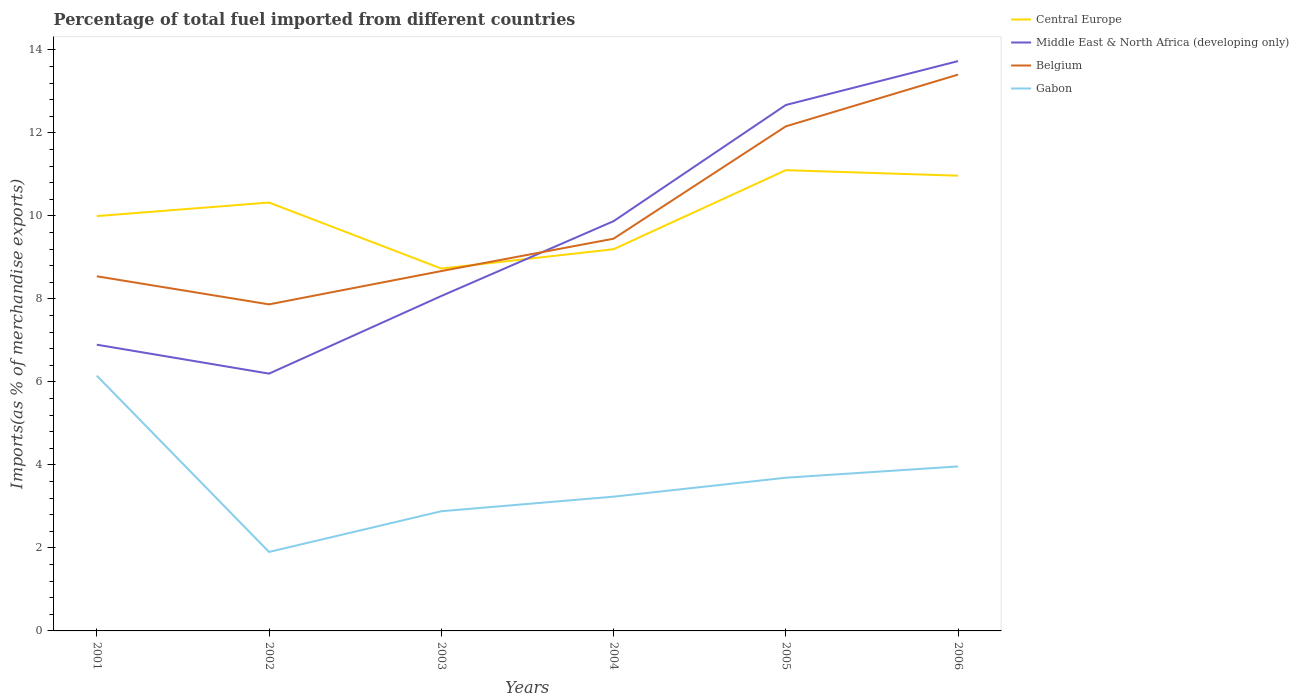Is the number of lines equal to the number of legend labels?
Offer a terse response. Yes. Across all years, what is the maximum percentage of imports to different countries in Gabon?
Offer a terse response. 1.9. What is the total percentage of imports to different countries in Belgium in the graph?
Your response must be concise. -4.73. What is the difference between the highest and the second highest percentage of imports to different countries in Belgium?
Keep it short and to the point. 5.54. Is the percentage of imports to different countries in Belgium strictly greater than the percentage of imports to different countries in Middle East & North Africa (developing only) over the years?
Give a very brief answer. No. How many years are there in the graph?
Ensure brevity in your answer.  6. What is the difference between two consecutive major ticks on the Y-axis?
Offer a terse response. 2. Are the values on the major ticks of Y-axis written in scientific E-notation?
Provide a short and direct response. No. Does the graph contain any zero values?
Provide a succinct answer. No. Does the graph contain grids?
Keep it short and to the point. No. How many legend labels are there?
Your answer should be compact. 4. What is the title of the graph?
Provide a succinct answer. Percentage of total fuel imported from different countries. Does "Dominica" appear as one of the legend labels in the graph?
Give a very brief answer. No. What is the label or title of the X-axis?
Ensure brevity in your answer.  Years. What is the label or title of the Y-axis?
Provide a short and direct response. Imports(as % of merchandise exports). What is the Imports(as % of merchandise exports) in Central Europe in 2001?
Offer a very short reply. 9.99. What is the Imports(as % of merchandise exports) in Middle East & North Africa (developing only) in 2001?
Provide a succinct answer. 6.9. What is the Imports(as % of merchandise exports) in Belgium in 2001?
Keep it short and to the point. 8.54. What is the Imports(as % of merchandise exports) in Gabon in 2001?
Your answer should be very brief. 6.15. What is the Imports(as % of merchandise exports) of Central Europe in 2002?
Give a very brief answer. 10.32. What is the Imports(as % of merchandise exports) of Middle East & North Africa (developing only) in 2002?
Give a very brief answer. 6.2. What is the Imports(as % of merchandise exports) of Belgium in 2002?
Make the answer very short. 7.87. What is the Imports(as % of merchandise exports) of Gabon in 2002?
Offer a very short reply. 1.9. What is the Imports(as % of merchandise exports) of Central Europe in 2003?
Your answer should be compact. 8.73. What is the Imports(as % of merchandise exports) in Middle East & North Africa (developing only) in 2003?
Offer a very short reply. 8.07. What is the Imports(as % of merchandise exports) in Belgium in 2003?
Keep it short and to the point. 8.67. What is the Imports(as % of merchandise exports) of Gabon in 2003?
Offer a terse response. 2.88. What is the Imports(as % of merchandise exports) in Central Europe in 2004?
Ensure brevity in your answer.  9.2. What is the Imports(as % of merchandise exports) of Middle East & North Africa (developing only) in 2004?
Your answer should be very brief. 9.87. What is the Imports(as % of merchandise exports) of Belgium in 2004?
Provide a short and direct response. 9.45. What is the Imports(as % of merchandise exports) in Gabon in 2004?
Offer a very short reply. 3.23. What is the Imports(as % of merchandise exports) in Central Europe in 2005?
Your answer should be compact. 11.1. What is the Imports(as % of merchandise exports) in Middle East & North Africa (developing only) in 2005?
Your response must be concise. 12.67. What is the Imports(as % of merchandise exports) of Belgium in 2005?
Your answer should be very brief. 12.16. What is the Imports(as % of merchandise exports) of Gabon in 2005?
Keep it short and to the point. 3.69. What is the Imports(as % of merchandise exports) in Central Europe in 2006?
Give a very brief answer. 10.97. What is the Imports(as % of merchandise exports) of Middle East & North Africa (developing only) in 2006?
Ensure brevity in your answer.  13.73. What is the Imports(as % of merchandise exports) in Belgium in 2006?
Provide a succinct answer. 13.4. What is the Imports(as % of merchandise exports) of Gabon in 2006?
Give a very brief answer. 3.96. Across all years, what is the maximum Imports(as % of merchandise exports) in Central Europe?
Ensure brevity in your answer.  11.1. Across all years, what is the maximum Imports(as % of merchandise exports) in Middle East & North Africa (developing only)?
Provide a short and direct response. 13.73. Across all years, what is the maximum Imports(as % of merchandise exports) in Belgium?
Provide a succinct answer. 13.4. Across all years, what is the maximum Imports(as % of merchandise exports) of Gabon?
Offer a very short reply. 6.15. Across all years, what is the minimum Imports(as % of merchandise exports) of Central Europe?
Keep it short and to the point. 8.73. Across all years, what is the minimum Imports(as % of merchandise exports) in Middle East & North Africa (developing only)?
Your answer should be very brief. 6.2. Across all years, what is the minimum Imports(as % of merchandise exports) of Belgium?
Give a very brief answer. 7.87. Across all years, what is the minimum Imports(as % of merchandise exports) of Gabon?
Give a very brief answer. 1.9. What is the total Imports(as % of merchandise exports) of Central Europe in the graph?
Make the answer very short. 60.31. What is the total Imports(as % of merchandise exports) in Middle East & North Africa (developing only) in the graph?
Provide a short and direct response. 57.44. What is the total Imports(as % of merchandise exports) in Belgium in the graph?
Offer a very short reply. 60.09. What is the total Imports(as % of merchandise exports) in Gabon in the graph?
Offer a terse response. 21.83. What is the difference between the Imports(as % of merchandise exports) in Central Europe in 2001 and that in 2002?
Offer a terse response. -0.33. What is the difference between the Imports(as % of merchandise exports) in Middle East & North Africa (developing only) in 2001 and that in 2002?
Your answer should be very brief. 0.7. What is the difference between the Imports(as % of merchandise exports) of Belgium in 2001 and that in 2002?
Provide a short and direct response. 0.68. What is the difference between the Imports(as % of merchandise exports) in Gabon in 2001 and that in 2002?
Your response must be concise. 4.25. What is the difference between the Imports(as % of merchandise exports) in Central Europe in 2001 and that in 2003?
Ensure brevity in your answer.  1.26. What is the difference between the Imports(as % of merchandise exports) of Middle East & North Africa (developing only) in 2001 and that in 2003?
Provide a short and direct response. -1.17. What is the difference between the Imports(as % of merchandise exports) in Belgium in 2001 and that in 2003?
Keep it short and to the point. -0.13. What is the difference between the Imports(as % of merchandise exports) of Gabon in 2001 and that in 2003?
Provide a succinct answer. 3.27. What is the difference between the Imports(as % of merchandise exports) of Central Europe in 2001 and that in 2004?
Provide a short and direct response. 0.8. What is the difference between the Imports(as % of merchandise exports) in Middle East & North Africa (developing only) in 2001 and that in 2004?
Offer a very short reply. -2.98. What is the difference between the Imports(as % of merchandise exports) of Belgium in 2001 and that in 2004?
Your response must be concise. -0.91. What is the difference between the Imports(as % of merchandise exports) in Gabon in 2001 and that in 2004?
Make the answer very short. 2.92. What is the difference between the Imports(as % of merchandise exports) in Central Europe in 2001 and that in 2005?
Give a very brief answer. -1.11. What is the difference between the Imports(as % of merchandise exports) in Middle East & North Africa (developing only) in 2001 and that in 2005?
Your answer should be very brief. -5.77. What is the difference between the Imports(as % of merchandise exports) in Belgium in 2001 and that in 2005?
Your answer should be very brief. -3.61. What is the difference between the Imports(as % of merchandise exports) of Gabon in 2001 and that in 2005?
Offer a very short reply. 2.46. What is the difference between the Imports(as % of merchandise exports) in Central Europe in 2001 and that in 2006?
Give a very brief answer. -0.97. What is the difference between the Imports(as % of merchandise exports) of Middle East & North Africa (developing only) in 2001 and that in 2006?
Make the answer very short. -6.83. What is the difference between the Imports(as % of merchandise exports) of Belgium in 2001 and that in 2006?
Offer a very short reply. -4.86. What is the difference between the Imports(as % of merchandise exports) in Gabon in 2001 and that in 2006?
Offer a very short reply. 2.19. What is the difference between the Imports(as % of merchandise exports) in Central Europe in 2002 and that in 2003?
Provide a short and direct response. 1.59. What is the difference between the Imports(as % of merchandise exports) in Middle East & North Africa (developing only) in 2002 and that in 2003?
Ensure brevity in your answer.  -1.87. What is the difference between the Imports(as % of merchandise exports) of Belgium in 2002 and that in 2003?
Your answer should be very brief. -0.8. What is the difference between the Imports(as % of merchandise exports) in Gabon in 2002 and that in 2003?
Give a very brief answer. -0.98. What is the difference between the Imports(as % of merchandise exports) of Middle East & North Africa (developing only) in 2002 and that in 2004?
Ensure brevity in your answer.  -3.67. What is the difference between the Imports(as % of merchandise exports) in Belgium in 2002 and that in 2004?
Keep it short and to the point. -1.58. What is the difference between the Imports(as % of merchandise exports) in Gabon in 2002 and that in 2004?
Offer a very short reply. -1.33. What is the difference between the Imports(as % of merchandise exports) of Central Europe in 2002 and that in 2005?
Your answer should be very brief. -0.78. What is the difference between the Imports(as % of merchandise exports) of Middle East & North Africa (developing only) in 2002 and that in 2005?
Offer a terse response. -6.47. What is the difference between the Imports(as % of merchandise exports) in Belgium in 2002 and that in 2005?
Offer a terse response. -4.29. What is the difference between the Imports(as % of merchandise exports) of Gabon in 2002 and that in 2005?
Give a very brief answer. -1.79. What is the difference between the Imports(as % of merchandise exports) of Central Europe in 2002 and that in 2006?
Provide a short and direct response. -0.65. What is the difference between the Imports(as % of merchandise exports) of Middle East & North Africa (developing only) in 2002 and that in 2006?
Keep it short and to the point. -7.53. What is the difference between the Imports(as % of merchandise exports) in Belgium in 2002 and that in 2006?
Your response must be concise. -5.54. What is the difference between the Imports(as % of merchandise exports) of Gabon in 2002 and that in 2006?
Provide a succinct answer. -2.06. What is the difference between the Imports(as % of merchandise exports) of Central Europe in 2003 and that in 2004?
Offer a terse response. -0.47. What is the difference between the Imports(as % of merchandise exports) of Middle East & North Africa (developing only) in 2003 and that in 2004?
Provide a short and direct response. -1.8. What is the difference between the Imports(as % of merchandise exports) in Belgium in 2003 and that in 2004?
Offer a terse response. -0.78. What is the difference between the Imports(as % of merchandise exports) in Gabon in 2003 and that in 2004?
Provide a short and direct response. -0.35. What is the difference between the Imports(as % of merchandise exports) of Central Europe in 2003 and that in 2005?
Ensure brevity in your answer.  -2.37. What is the difference between the Imports(as % of merchandise exports) in Middle East & North Africa (developing only) in 2003 and that in 2005?
Provide a short and direct response. -4.6. What is the difference between the Imports(as % of merchandise exports) of Belgium in 2003 and that in 2005?
Ensure brevity in your answer.  -3.49. What is the difference between the Imports(as % of merchandise exports) of Gabon in 2003 and that in 2005?
Provide a succinct answer. -0.81. What is the difference between the Imports(as % of merchandise exports) in Central Europe in 2003 and that in 2006?
Your response must be concise. -2.24. What is the difference between the Imports(as % of merchandise exports) in Middle East & North Africa (developing only) in 2003 and that in 2006?
Offer a very short reply. -5.66. What is the difference between the Imports(as % of merchandise exports) of Belgium in 2003 and that in 2006?
Provide a short and direct response. -4.73. What is the difference between the Imports(as % of merchandise exports) in Gabon in 2003 and that in 2006?
Provide a short and direct response. -1.08. What is the difference between the Imports(as % of merchandise exports) of Central Europe in 2004 and that in 2005?
Your answer should be compact. -1.9. What is the difference between the Imports(as % of merchandise exports) in Middle East & North Africa (developing only) in 2004 and that in 2005?
Your answer should be very brief. -2.8. What is the difference between the Imports(as % of merchandise exports) in Belgium in 2004 and that in 2005?
Give a very brief answer. -2.71. What is the difference between the Imports(as % of merchandise exports) in Gabon in 2004 and that in 2005?
Keep it short and to the point. -0.46. What is the difference between the Imports(as % of merchandise exports) of Central Europe in 2004 and that in 2006?
Provide a succinct answer. -1.77. What is the difference between the Imports(as % of merchandise exports) of Middle East & North Africa (developing only) in 2004 and that in 2006?
Offer a terse response. -3.86. What is the difference between the Imports(as % of merchandise exports) in Belgium in 2004 and that in 2006?
Your response must be concise. -3.95. What is the difference between the Imports(as % of merchandise exports) in Gabon in 2004 and that in 2006?
Your response must be concise. -0.73. What is the difference between the Imports(as % of merchandise exports) of Central Europe in 2005 and that in 2006?
Make the answer very short. 0.13. What is the difference between the Imports(as % of merchandise exports) of Middle East & North Africa (developing only) in 2005 and that in 2006?
Make the answer very short. -1.06. What is the difference between the Imports(as % of merchandise exports) in Belgium in 2005 and that in 2006?
Your answer should be compact. -1.25. What is the difference between the Imports(as % of merchandise exports) of Gabon in 2005 and that in 2006?
Offer a very short reply. -0.27. What is the difference between the Imports(as % of merchandise exports) in Central Europe in 2001 and the Imports(as % of merchandise exports) in Middle East & North Africa (developing only) in 2002?
Ensure brevity in your answer.  3.8. What is the difference between the Imports(as % of merchandise exports) in Central Europe in 2001 and the Imports(as % of merchandise exports) in Belgium in 2002?
Give a very brief answer. 2.13. What is the difference between the Imports(as % of merchandise exports) of Central Europe in 2001 and the Imports(as % of merchandise exports) of Gabon in 2002?
Your answer should be very brief. 8.09. What is the difference between the Imports(as % of merchandise exports) of Middle East & North Africa (developing only) in 2001 and the Imports(as % of merchandise exports) of Belgium in 2002?
Provide a succinct answer. -0.97. What is the difference between the Imports(as % of merchandise exports) in Middle East & North Africa (developing only) in 2001 and the Imports(as % of merchandise exports) in Gabon in 2002?
Your response must be concise. 4.99. What is the difference between the Imports(as % of merchandise exports) in Belgium in 2001 and the Imports(as % of merchandise exports) in Gabon in 2002?
Keep it short and to the point. 6.64. What is the difference between the Imports(as % of merchandise exports) of Central Europe in 2001 and the Imports(as % of merchandise exports) of Middle East & North Africa (developing only) in 2003?
Provide a short and direct response. 1.93. What is the difference between the Imports(as % of merchandise exports) of Central Europe in 2001 and the Imports(as % of merchandise exports) of Belgium in 2003?
Make the answer very short. 1.32. What is the difference between the Imports(as % of merchandise exports) in Central Europe in 2001 and the Imports(as % of merchandise exports) in Gabon in 2003?
Keep it short and to the point. 7.11. What is the difference between the Imports(as % of merchandise exports) of Middle East & North Africa (developing only) in 2001 and the Imports(as % of merchandise exports) of Belgium in 2003?
Keep it short and to the point. -1.77. What is the difference between the Imports(as % of merchandise exports) of Middle East & North Africa (developing only) in 2001 and the Imports(as % of merchandise exports) of Gabon in 2003?
Offer a very short reply. 4.01. What is the difference between the Imports(as % of merchandise exports) in Belgium in 2001 and the Imports(as % of merchandise exports) in Gabon in 2003?
Make the answer very short. 5.66. What is the difference between the Imports(as % of merchandise exports) of Central Europe in 2001 and the Imports(as % of merchandise exports) of Middle East & North Africa (developing only) in 2004?
Offer a terse response. 0.12. What is the difference between the Imports(as % of merchandise exports) of Central Europe in 2001 and the Imports(as % of merchandise exports) of Belgium in 2004?
Your response must be concise. 0.54. What is the difference between the Imports(as % of merchandise exports) of Central Europe in 2001 and the Imports(as % of merchandise exports) of Gabon in 2004?
Offer a terse response. 6.76. What is the difference between the Imports(as % of merchandise exports) of Middle East & North Africa (developing only) in 2001 and the Imports(as % of merchandise exports) of Belgium in 2004?
Your answer should be very brief. -2.55. What is the difference between the Imports(as % of merchandise exports) in Middle East & North Africa (developing only) in 2001 and the Imports(as % of merchandise exports) in Gabon in 2004?
Offer a very short reply. 3.66. What is the difference between the Imports(as % of merchandise exports) in Belgium in 2001 and the Imports(as % of merchandise exports) in Gabon in 2004?
Ensure brevity in your answer.  5.31. What is the difference between the Imports(as % of merchandise exports) of Central Europe in 2001 and the Imports(as % of merchandise exports) of Middle East & North Africa (developing only) in 2005?
Your answer should be very brief. -2.68. What is the difference between the Imports(as % of merchandise exports) in Central Europe in 2001 and the Imports(as % of merchandise exports) in Belgium in 2005?
Give a very brief answer. -2.16. What is the difference between the Imports(as % of merchandise exports) in Central Europe in 2001 and the Imports(as % of merchandise exports) in Gabon in 2005?
Your answer should be compact. 6.3. What is the difference between the Imports(as % of merchandise exports) of Middle East & North Africa (developing only) in 2001 and the Imports(as % of merchandise exports) of Belgium in 2005?
Provide a short and direct response. -5.26. What is the difference between the Imports(as % of merchandise exports) in Middle East & North Africa (developing only) in 2001 and the Imports(as % of merchandise exports) in Gabon in 2005?
Give a very brief answer. 3.21. What is the difference between the Imports(as % of merchandise exports) in Belgium in 2001 and the Imports(as % of merchandise exports) in Gabon in 2005?
Your answer should be very brief. 4.85. What is the difference between the Imports(as % of merchandise exports) of Central Europe in 2001 and the Imports(as % of merchandise exports) of Middle East & North Africa (developing only) in 2006?
Your answer should be very brief. -3.73. What is the difference between the Imports(as % of merchandise exports) in Central Europe in 2001 and the Imports(as % of merchandise exports) in Belgium in 2006?
Your answer should be very brief. -3.41. What is the difference between the Imports(as % of merchandise exports) in Central Europe in 2001 and the Imports(as % of merchandise exports) in Gabon in 2006?
Provide a short and direct response. 6.03. What is the difference between the Imports(as % of merchandise exports) in Middle East & North Africa (developing only) in 2001 and the Imports(as % of merchandise exports) in Belgium in 2006?
Your answer should be compact. -6.51. What is the difference between the Imports(as % of merchandise exports) in Middle East & North Africa (developing only) in 2001 and the Imports(as % of merchandise exports) in Gabon in 2006?
Offer a very short reply. 2.93. What is the difference between the Imports(as % of merchandise exports) in Belgium in 2001 and the Imports(as % of merchandise exports) in Gabon in 2006?
Offer a terse response. 4.58. What is the difference between the Imports(as % of merchandise exports) in Central Europe in 2002 and the Imports(as % of merchandise exports) in Middle East & North Africa (developing only) in 2003?
Make the answer very short. 2.25. What is the difference between the Imports(as % of merchandise exports) in Central Europe in 2002 and the Imports(as % of merchandise exports) in Belgium in 2003?
Offer a terse response. 1.65. What is the difference between the Imports(as % of merchandise exports) in Central Europe in 2002 and the Imports(as % of merchandise exports) in Gabon in 2003?
Offer a terse response. 7.44. What is the difference between the Imports(as % of merchandise exports) of Middle East & North Africa (developing only) in 2002 and the Imports(as % of merchandise exports) of Belgium in 2003?
Ensure brevity in your answer.  -2.47. What is the difference between the Imports(as % of merchandise exports) of Middle East & North Africa (developing only) in 2002 and the Imports(as % of merchandise exports) of Gabon in 2003?
Ensure brevity in your answer.  3.32. What is the difference between the Imports(as % of merchandise exports) in Belgium in 2002 and the Imports(as % of merchandise exports) in Gabon in 2003?
Offer a terse response. 4.98. What is the difference between the Imports(as % of merchandise exports) of Central Europe in 2002 and the Imports(as % of merchandise exports) of Middle East & North Africa (developing only) in 2004?
Offer a very short reply. 0.45. What is the difference between the Imports(as % of merchandise exports) in Central Europe in 2002 and the Imports(as % of merchandise exports) in Belgium in 2004?
Your response must be concise. 0.87. What is the difference between the Imports(as % of merchandise exports) in Central Europe in 2002 and the Imports(as % of merchandise exports) in Gabon in 2004?
Offer a very short reply. 7.09. What is the difference between the Imports(as % of merchandise exports) of Middle East & North Africa (developing only) in 2002 and the Imports(as % of merchandise exports) of Belgium in 2004?
Ensure brevity in your answer.  -3.25. What is the difference between the Imports(as % of merchandise exports) in Middle East & North Africa (developing only) in 2002 and the Imports(as % of merchandise exports) in Gabon in 2004?
Provide a succinct answer. 2.96. What is the difference between the Imports(as % of merchandise exports) in Belgium in 2002 and the Imports(as % of merchandise exports) in Gabon in 2004?
Make the answer very short. 4.63. What is the difference between the Imports(as % of merchandise exports) of Central Europe in 2002 and the Imports(as % of merchandise exports) of Middle East & North Africa (developing only) in 2005?
Your response must be concise. -2.35. What is the difference between the Imports(as % of merchandise exports) in Central Europe in 2002 and the Imports(as % of merchandise exports) in Belgium in 2005?
Your response must be concise. -1.84. What is the difference between the Imports(as % of merchandise exports) of Central Europe in 2002 and the Imports(as % of merchandise exports) of Gabon in 2005?
Make the answer very short. 6.63. What is the difference between the Imports(as % of merchandise exports) of Middle East & North Africa (developing only) in 2002 and the Imports(as % of merchandise exports) of Belgium in 2005?
Your answer should be compact. -5.96. What is the difference between the Imports(as % of merchandise exports) of Middle East & North Africa (developing only) in 2002 and the Imports(as % of merchandise exports) of Gabon in 2005?
Keep it short and to the point. 2.51. What is the difference between the Imports(as % of merchandise exports) of Belgium in 2002 and the Imports(as % of merchandise exports) of Gabon in 2005?
Your response must be concise. 4.18. What is the difference between the Imports(as % of merchandise exports) in Central Europe in 2002 and the Imports(as % of merchandise exports) in Middle East & North Africa (developing only) in 2006?
Your answer should be very brief. -3.41. What is the difference between the Imports(as % of merchandise exports) of Central Europe in 2002 and the Imports(as % of merchandise exports) of Belgium in 2006?
Keep it short and to the point. -3.08. What is the difference between the Imports(as % of merchandise exports) in Central Europe in 2002 and the Imports(as % of merchandise exports) in Gabon in 2006?
Ensure brevity in your answer.  6.36. What is the difference between the Imports(as % of merchandise exports) in Middle East & North Africa (developing only) in 2002 and the Imports(as % of merchandise exports) in Belgium in 2006?
Your response must be concise. -7.2. What is the difference between the Imports(as % of merchandise exports) of Middle East & North Africa (developing only) in 2002 and the Imports(as % of merchandise exports) of Gabon in 2006?
Keep it short and to the point. 2.24. What is the difference between the Imports(as % of merchandise exports) in Belgium in 2002 and the Imports(as % of merchandise exports) in Gabon in 2006?
Make the answer very short. 3.9. What is the difference between the Imports(as % of merchandise exports) of Central Europe in 2003 and the Imports(as % of merchandise exports) of Middle East & North Africa (developing only) in 2004?
Provide a succinct answer. -1.14. What is the difference between the Imports(as % of merchandise exports) in Central Europe in 2003 and the Imports(as % of merchandise exports) in Belgium in 2004?
Your response must be concise. -0.72. What is the difference between the Imports(as % of merchandise exports) of Central Europe in 2003 and the Imports(as % of merchandise exports) of Gabon in 2004?
Make the answer very short. 5.5. What is the difference between the Imports(as % of merchandise exports) in Middle East & North Africa (developing only) in 2003 and the Imports(as % of merchandise exports) in Belgium in 2004?
Provide a short and direct response. -1.38. What is the difference between the Imports(as % of merchandise exports) of Middle East & North Africa (developing only) in 2003 and the Imports(as % of merchandise exports) of Gabon in 2004?
Offer a terse response. 4.83. What is the difference between the Imports(as % of merchandise exports) in Belgium in 2003 and the Imports(as % of merchandise exports) in Gabon in 2004?
Keep it short and to the point. 5.44. What is the difference between the Imports(as % of merchandise exports) in Central Europe in 2003 and the Imports(as % of merchandise exports) in Middle East & North Africa (developing only) in 2005?
Provide a succinct answer. -3.94. What is the difference between the Imports(as % of merchandise exports) of Central Europe in 2003 and the Imports(as % of merchandise exports) of Belgium in 2005?
Provide a succinct answer. -3.43. What is the difference between the Imports(as % of merchandise exports) of Central Europe in 2003 and the Imports(as % of merchandise exports) of Gabon in 2005?
Provide a short and direct response. 5.04. What is the difference between the Imports(as % of merchandise exports) in Middle East & North Africa (developing only) in 2003 and the Imports(as % of merchandise exports) in Belgium in 2005?
Your answer should be very brief. -4.09. What is the difference between the Imports(as % of merchandise exports) of Middle East & North Africa (developing only) in 2003 and the Imports(as % of merchandise exports) of Gabon in 2005?
Ensure brevity in your answer.  4.38. What is the difference between the Imports(as % of merchandise exports) of Belgium in 2003 and the Imports(as % of merchandise exports) of Gabon in 2005?
Make the answer very short. 4.98. What is the difference between the Imports(as % of merchandise exports) in Central Europe in 2003 and the Imports(as % of merchandise exports) in Middle East & North Africa (developing only) in 2006?
Give a very brief answer. -5. What is the difference between the Imports(as % of merchandise exports) of Central Europe in 2003 and the Imports(as % of merchandise exports) of Belgium in 2006?
Give a very brief answer. -4.67. What is the difference between the Imports(as % of merchandise exports) of Central Europe in 2003 and the Imports(as % of merchandise exports) of Gabon in 2006?
Provide a succinct answer. 4.77. What is the difference between the Imports(as % of merchandise exports) of Middle East & North Africa (developing only) in 2003 and the Imports(as % of merchandise exports) of Belgium in 2006?
Your response must be concise. -5.33. What is the difference between the Imports(as % of merchandise exports) in Middle East & North Africa (developing only) in 2003 and the Imports(as % of merchandise exports) in Gabon in 2006?
Provide a short and direct response. 4.11. What is the difference between the Imports(as % of merchandise exports) in Belgium in 2003 and the Imports(as % of merchandise exports) in Gabon in 2006?
Your answer should be very brief. 4.71. What is the difference between the Imports(as % of merchandise exports) in Central Europe in 2004 and the Imports(as % of merchandise exports) in Middle East & North Africa (developing only) in 2005?
Ensure brevity in your answer.  -3.47. What is the difference between the Imports(as % of merchandise exports) in Central Europe in 2004 and the Imports(as % of merchandise exports) in Belgium in 2005?
Your response must be concise. -2.96. What is the difference between the Imports(as % of merchandise exports) in Central Europe in 2004 and the Imports(as % of merchandise exports) in Gabon in 2005?
Make the answer very short. 5.51. What is the difference between the Imports(as % of merchandise exports) of Middle East & North Africa (developing only) in 2004 and the Imports(as % of merchandise exports) of Belgium in 2005?
Keep it short and to the point. -2.28. What is the difference between the Imports(as % of merchandise exports) of Middle East & North Africa (developing only) in 2004 and the Imports(as % of merchandise exports) of Gabon in 2005?
Your response must be concise. 6.18. What is the difference between the Imports(as % of merchandise exports) of Belgium in 2004 and the Imports(as % of merchandise exports) of Gabon in 2005?
Keep it short and to the point. 5.76. What is the difference between the Imports(as % of merchandise exports) of Central Europe in 2004 and the Imports(as % of merchandise exports) of Middle East & North Africa (developing only) in 2006?
Your answer should be very brief. -4.53. What is the difference between the Imports(as % of merchandise exports) in Central Europe in 2004 and the Imports(as % of merchandise exports) in Belgium in 2006?
Your answer should be very brief. -4.21. What is the difference between the Imports(as % of merchandise exports) of Central Europe in 2004 and the Imports(as % of merchandise exports) of Gabon in 2006?
Offer a terse response. 5.23. What is the difference between the Imports(as % of merchandise exports) in Middle East & North Africa (developing only) in 2004 and the Imports(as % of merchandise exports) in Belgium in 2006?
Your answer should be very brief. -3.53. What is the difference between the Imports(as % of merchandise exports) of Middle East & North Africa (developing only) in 2004 and the Imports(as % of merchandise exports) of Gabon in 2006?
Offer a terse response. 5.91. What is the difference between the Imports(as % of merchandise exports) of Belgium in 2004 and the Imports(as % of merchandise exports) of Gabon in 2006?
Ensure brevity in your answer.  5.49. What is the difference between the Imports(as % of merchandise exports) of Central Europe in 2005 and the Imports(as % of merchandise exports) of Middle East & North Africa (developing only) in 2006?
Offer a terse response. -2.63. What is the difference between the Imports(as % of merchandise exports) in Central Europe in 2005 and the Imports(as % of merchandise exports) in Belgium in 2006?
Keep it short and to the point. -2.3. What is the difference between the Imports(as % of merchandise exports) of Central Europe in 2005 and the Imports(as % of merchandise exports) of Gabon in 2006?
Provide a short and direct response. 7.14. What is the difference between the Imports(as % of merchandise exports) in Middle East & North Africa (developing only) in 2005 and the Imports(as % of merchandise exports) in Belgium in 2006?
Your response must be concise. -0.73. What is the difference between the Imports(as % of merchandise exports) in Middle East & North Africa (developing only) in 2005 and the Imports(as % of merchandise exports) in Gabon in 2006?
Your answer should be very brief. 8.71. What is the difference between the Imports(as % of merchandise exports) in Belgium in 2005 and the Imports(as % of merchandise exports) in Gabon in 2006?
Give a very brief answer. 8.19. What is the average Imports(as % of merchandise exports) in Central Europe per year?
Your answer should be compact. 10.05. What is the average Imports(as % of merchandise exports) of Middle East & North Africa (developing only) per year?
Keep it short and to the point. 9.57. What is the average Imports(as % of merchandise exports) of Belgium per year?
Provide a short and direct response. 10.02. What is the average Imports(as % of merchandise exports) in Gabon per year?
Provide a short and direct response. 3.64. In the year 2001, what is the difference between the Imports(as % of merchandise exports) in Central Europe and Imports(as % of merchandise exports) in Middle East & North Africa (developing only)?
Give a very brief answer. 3.1. In the year 2001, what is the difference between the Imports(as % of merchandise exports) in Central Europe and Imports(as % of merchandise exports) in Belgium?
Your answer should be very brief. 1.45. In the year 2001, what is the difference between the Imports(as % of merchandise exports) in Central Europe and Imports(as % of merchandise exports) in Gabon?
Provide a succinct answer. 3.84. In the year 2001, what is the difference between the Imports(as % of merchandise exports) in Middle East & North Africa (developing only) and Imports(as % of merchandise exports) in Belgium?
Your answer should be compact. -1.65. In the year 2001, what is the difference between the Imports(as % of merchandise exports) in Middle East & North Africa (developing only) and Imports(as % of merchandise exports) in Gabon?
Provide a succinct answer. 0.75. In the year 2001, what is the difference between the Imports(as % of merchandise exports) in Belgium and Imports(as % of merchandise exports) in Gabon?
Your response must be concise. 2.39. In the year 2002, what is the difference between the Imports(as % of merchandise exports) of Central Europe and Imports(as % of merchandise exports) of Middle East & North Africa (developing only)?
Offer a very short reply. 4.12. In the year 2002, what is the difference between the Imports(as % of merchandise exports) of Central Europe and Imports(as % of merchandise exports) of Belgium?
Your response must be concise. 2.45. In the year 2002, what is the difference between the Imports(as % of merchandise exports) of Central Europe and Imports(as % of merchandise exports) of Gabon?
Offer a terse response. 8.42. In the year 2002, what is the difference between the Imports(as % of merchandise exports) in Middle East & North Africa (developing only) and Imports(as % of merchandise exports) in Belgium?
Make the answer very short. -1.67. In the year 2002, what is the difference between the Imports(as % of merchandise exports) of Middle East & North Africa (developing only) and Imports(as % of merchandise exports) of Gabon?
Provide a short and direct response. 4.3. In the year 2002, what is the difference between the Imports(as % of merchandise exports) of Belgium and Imports(as % of merchandise exports) of Gabon?
Provide a succinct answer. 5.97. In the year 2003, what is the difference between the Imports(as % of merchandise exports) in Central Europe and Imports(as % of merchandise exports) in Middle East & North Africa (developing only)?
Keep it short and to the point. 0.66. In the year 2003, what is the difference between the Imports(as % of merchandise exports) in Central Europe and Imports(as % of merchandise exports) in Belgium?
Make the answer very short. 0.06. In the year 2003, what is the difference between the Imports(as % of merchandise exports) of Central Europe and Imports(as % of merchandise exports) of Gabon?
Your response must be concise. 5.85. In the year 2003, what is the difference between the Imports(as % of merchandise exports) in Middle East & North Africa (developing only) and Imports(as % of merchandise exports) in Belgium?
Your answer should be compact. -0.6. In the year 2003, what is the difference between the Imports(as % of merchandise exports) in Middle East & North Africa (developing only) and Imports(as % of merchandise exports) in Gabon?
Provide a succinct answer. 5.19. In the year 2003, what is the difference between the Imports(as % of merchandise exports) of Belgium and Imports(as % of merchandise exports) of Gabon?
Provide a short and direct response. 5.79. In the year 2004, what is the difference between the Imports(as % of merchandise exports) of Central Europe and Imports(as % of merchandise exports) of Middle East & North Africa (developing only)?
Offer a terse response. -0.68. In the year 2004, what is the difference between the Imports(as % of merchandise exports) of Central Europe and Imports(as % of merchandise exports) of Belgium?
Make the answer very short. -0.25. In the year 2004, what is the difference between the Imports(as % of merchandise exports) of Central Europe and Imports(as % of merchandise exports) of Gabon?
Offer a very short reply. 5.96. In the year 2004, what is the difference between the Imports(as % of merchandise exports) of Middle East & North Africa (developing only) and Imports(as % of merchandise exports) of Belgium?
Provide a succinct answer. 0.42. In the year 2004, what is the difference between the Imports(as % of merchandise exports) in Middle East & North Africa (developing only) and Imports(as % of merchandise exports) in Gabon?
Ensure brevity in your answer.  6.64. In the year 2004, what is the difference between the Imports(as % of merchandise exports) of Belgium and Imports(as % of merchandise exports) of Gabon?
Offer a terse response. 6.22. In the year 2005, what is the difference between the Imports(as % of merchandise exports) in Central Europe and Imports(as % of merchandise exports) in Middle East & North Africa (developing only)?
Ensure brevity in your answer.  -1.57. In the year 2005, what is the difference between the Imports(as % of merchandise exports) of Central Europe and Imports(as % of merchandise exports) of Belgium?
Ensure brevity in your answer.  -1.06. In the year 2005, what is the difference between the Imports(as % of merchandise exports) of Central Europe and Imports(as % of merchandise exports) of Gabon?
Ensure brevity in your answer.  7.41. In the year 2005, what is the difference between the Imports(as % of merchandise exports) in Middle East & North Africa (developing only) and Imports(as % of merchandise exports) in Belgium?
Offer a very short reply. 0.51. In the year 2005, what is the difference between the Imports(as % of merchandise exports) in Middle East & North Africa (developing only) and Imports(as % of merchandise exports) in Gabon?
Provide a short and direct response. 8.98. In the year 2005, what is the difference between the Imports(as % of merchandise exports) in Belgium and Imports(as % of merchandise exports) in Gabon?
Your response must be concise. 8.47. In the year 2006, what is the difference between the Imports(as % of merchandise exports) of Central Europe and Imports(as % of merchandise exports) of Middle East & North Africa (developing only)?
Your response must be concise. -2.76. In the year 2006, what is the difference between the Imports(as % of merchandise exports) of Central Europe and Imports(as % of merchandise exports) of Belgium?
Provide a short and direct response. -2.44. In the year 2006, what is the difference between the Imports(as % of merchandise exports) of Central Europe and Imports(as % of merchandise exports) of Gabon?
Offer a very short reply. 7.01. In the year 2006, what is the difference between the Imports(as % of merchandise exports) in Middle East & North Africa (developing only) and Imports(as % of merchandise exports) in Belgium?
Offer a terse response. 0.33. In the year 2006, what is the difference between the Imports(as % of merchandise exports) of Middle East & North Africa (developing only) and Imports(as % of merchandise exports) of Gabon?
Give a very brief answer. 9.77. In the year 2006, what is the difference between the Imports(as % of merchandise exports) in Belgium and Imports(as % of merchandise exports) in Gabon?
Provide a short and direct response. 9.44. What is the ratio of the Imports(as % of merchandise exports) of Central Europe in 2001 to that in 2002?
Offer a terse response. 0.97. What is the ratio of the Imports(as % of merchandise exports) of Middle East & North Africa (developing only) in 2001 to that in 2002?
Offer a very short reply. 1.11. What is the ratio of the Imports(as % of merchandise exports) in Belgium in 2001 to that in 2002?
Give a very brief answer. 1.09. What is the ratio of the Imports(as % of merchandise exports) in Gabon in 2001 to that in 2002?
Provide a short and direct response. 3.23. What is the ratio of the Imports(as % of merchandise exports) of Central Europe in 2001 to that in 2003?
Your answer should be compact. 1.14. What is the ratio of the Imports(as % of merchandise exports) of Middle East & North Africa (developing only) in 2001 to that in 2003?
Ensure brevity in your answer.  0.85. What is the ratio of the Imports(as % of merchandise exports) in Belgium in 2001 to that in 2003?
Ensure brevity in your answer.  0.99. What is the ratio of the Imports(as % of merchandise exports) in Gabon in 2001 to that in 2003?
Provide a succinct answer. 2.13. What is the ratio of the Imports(as % of merchandise exports) of Central Europe in 2001 to that in 2004?
Give a very brief answer. 1.09. What is the ratio of the Imports(as % of merchandise exports) in Middle East & North Africa (developing only) in 2001 to that in 2004?
Make the answer very short. 0.7. What is the ratio of the Imports(as % of merchandise exports) of Belgium in 2001 to that in 2004?
Provide a succinct answer. 0.9. What is the ratio of the Imports(as % of merchandise exports) of Gabon in 2001 to that in 2004?
Ensure brevity in your answer.  1.9. What is the ratio of the Imports(as % of merchandise exports) in Central Europe in 2001 to that in 2005?
Provide a succinct answer. 0.9. What is the ratio of the Imports(as % of merchandise exports) of Middle East & North Africa (developing only) in 2001 to that in 2005?
Your response must be concise. 0.54. What is the ratio of the Imports(as % of merchandise exports) of Belgium in 2001 to that in 2005?
Your response must be concise. 0.7. What is the ratio of the Imports(as % of merchandise exports) of Gabon in 2001 to that in 2005?
Provide a succinct answer. 1.67. What is the ratio of the Imports(as % of merchandise exports) of Central Europe in 2001 to that in 2006?
Provide a succinct answer. 0.91. What is the ratio of the Imports(as % of merchandise exports) of Middle East & North Africa (developing only) in 2001 to that in 2006?
Make the answer very short. 0.5. What is the ratio of the Imports(as % of merchandise exports) in Belgium in 2001 to that in 2006?
Ensure brevity in your answer.  0.64. What is the ratio of the Imports(as % of merchandise exports) in Gabon in 2001 to that in 2006?
Offer a terse response. 1.55. What is the ratio of the Imports(as % of merchandise exports) in Central Europe in 2002 to that in 2003?
Your answer should be compact. 1.18. What is the ratio of the Imports(as % of merchandise exports) in Middle East & North Africa (developing only) in 2002 to that in 2003?
Your response must be concise. 0.77. What is the ratio of the Imports(as % of merchandise exports) in Belgium in 2002 to that in 2003?
Give a very brief answer. 0.91. What is the ratio of the Imports(as % of merchandise exports) of Gabon in 2002 to that in 2003?
Your answer should be compact. 0.66. What is the ratio of the Imports(as % of merchandise exports) in Central Europe in 2002 to that in 2004?
Your answer should be very brief. 1.12. What is the ratio of the Imports(as % of merchandise exports) in Middle East & North Africa (developing only) in 2002 to that in 2004?
Ensure brevity in your answer.  0.63. What is the ratio of the Imports(as % of merchandise exports) of Belgium in 2002 to that in 2004?
Offer a very short reply. 0.83. What is the ratio of the Imports(as % of merchandise exports) of Gabon in 2002 to that in 2004?
Ensure brevity in your answer.  0.59. What is the ratio of the Imports(as % of merchandise exports) in Central Europe in 2002 to that in 2005?
Provide a short and direct response. 0.93. What is the ratio of the Imports(as % of merchandise exports) in Middle East & North Africa (developing only) in 2002 to that in 2005?
Give a very brief answer. 0.49. What is the ratio of the Imports(as % of merchandise exports) in Belgium in 2002 to that in 2005?
Make the answer very short. 0.65. What is the ratio of the Imports(as % of merchandise exports) in Gabon in 2002 to that in 2005?
Ensure brevity in your answer.  0.52. What is the ratio of the Imports(as % of merchandise exports) in Central Europe in 2002 to that in 2006?
Offer a terse response. 0.94. What is the ratio of the Imports(as % of merchandise exports) of Middle East & North Africa (developing only) in 2002 to that in 2006?
Your answer should be compact. 0.45. What is the ratio of the Imports(as % of merchandise exports) in Belgium in 2002 to that in 2006?
Ensure brevity in your answer.  0.59. What is the ratio of the Imports(as % of merchandise exports) of Gabon in 2002 to that in 2006?
Offer a very short reply. 0.48. What is the ratio of the Imports(as % of merchandise exports) of Central Europe in 2003 to that in 2004?
Provide a succinct answer. 0.95. What is the ratio of the Imports(as % of merchandise exports) of Middle East & North Africa (developing only) in 2003 to that in 2004?
Your answer should be very brief. 0.82. What is the ratio of the Imports(as % of merchandise exports) in Belgium in 2003 to that in 2004?
Your response must be concise. 0.92. What is the ratio of the Imports(as % of merchandise exports) in Gabon in 2003 to that in 2004?
Make the answer very short. 0.89. What is the ratio of the Imports(as % of merchandise exports) of Central Europe in 2003 to that in 2005?
Offer a terse response. 0.79. What is the ratio of the Imports(as % of merchandise exports) of Middle East & North Africa (developing only) in 2003 to that in 2005?
Keep it short and to the point. 0.64. What is the ratio of the Imports(as % of merchandise exports) of Belgium in 2003 to that in 2005?
Provide a short and direct response. 0.71. What is the ratio of the Imports(as % of merchandise exports) of Gabon in 2003 to that in 2005?
Your answer should be very brief. 0.78. What is the ratio of the Imports(as % of merchandise exports) in Central Europe in 2003 to that in 2006?
Provide a succinct answer. 0.8. What is the ratio of the Imports(as % of merchandise exports) of Middle East & North Africa (developing only) in 2003 to that in 2006?
Ensure brevity in your answer.  0.59. What is the ratio of the Imports(as % of merchandise exports) of Belgium in 2003 to that in 2006?
Provide a short and direct response. 0.65. What is the ratio of the Imports(as % of merchandise exports) in Gabon in 2003 to that in 2006?
Your answer should be compact. 0.73. What is the ratio of the Imports(as % of merchandise exports) of Central Europe in 2004 to that in 2005?
Keep it short and to the point. 0.83. What is the ratio of the Imports(as % of merchandise exports) of Middle East & North Africa (developing only) in 2004 to that in 2005?
Your response must be concise. 0.78. What is the ratio of the Imports(as % of merchandise exports) of Belgium in 2004 to that in 2005?
Provide a short and direct response. 0.78. What is the ratio of the Imports(as % of merchandise exports) in Gabon in 2004 to that in 2005?
Offer a terse response. 0.88. What is the ratio of the Imports(as % of merchandise exports) in Central Europe in 2004 to that in 2006?
Provide a short and direct response. 0.84. What is the ratio of the Imports(as % of merchandise exports) in Middle East & North Africa (developing only) in 2004 to that in 2006?
Your answer should be very brief. 0.72. What is the ratio of the Imports(as % of merchandise exports) in Belgium in 2004 to that in 2006?
Keep it short and to the point. 0.71. What is the ratio of the Imports(as % of merchandise exports) in Gabon in 2004 to that in 2006?
Make the answer very short. 0.82. What is the ratio of the Imports(as % of merchandise exports) of Central Europe in 2005 to that in 2006?
Your response must be concise. 1.01. What is the ratio of the Imports(as % of merchandise exports) in Middle East & North Africa (developing only) in 2005 to that in 2006?
Provide a short and direct response. 0.92. What is the ratio of the Imports(as % of merchandise exports) of Belgium in 2005 to that in 2006?
Make the answer very short. 0.91. What is the ratio of the Imports(as % of merchandise exports) in Gabon in 2005 to that in 2006?
Offer a very short reply. 0.93. What is the difference between the highest and the second highest Imports(as % of merchandise exports) in Central Europe?
Offer a terse response. 0.13. What is the difference between the highest and the second highest Imports(as % of merchandise exports) of Middle East & North Africa (developing only)?
Provide a succinct answer. 1.06. What is the difference between the highest and the second highest Imports(as % of merchandise exports) of Belgium?
Make the answer very short. 1.25. What is the difference between the highest and the second highest Imports(as % of merchandise exports) of Gabon?
Provide a short and direct response. 2.19. What is the difference between the highest and the lowest Imports(as % of merchandise exports) in Central Europe?
Your answer should be very brief. 2.37. What is the difference between the highest and the lowest Imports(as % of merchandise exports) in Middle East & North Africa (developing only)?
Make the answer very short. 7.53. What is the difference between the highest and the lowest Imports(as % of merchandise exports) of Belgium?
Make the answer very short. 5.54. What is the difference between the highest and the lowest Imports(as % of merchandise exports) in Gabon?
Give a very brief answer. 4.25. 